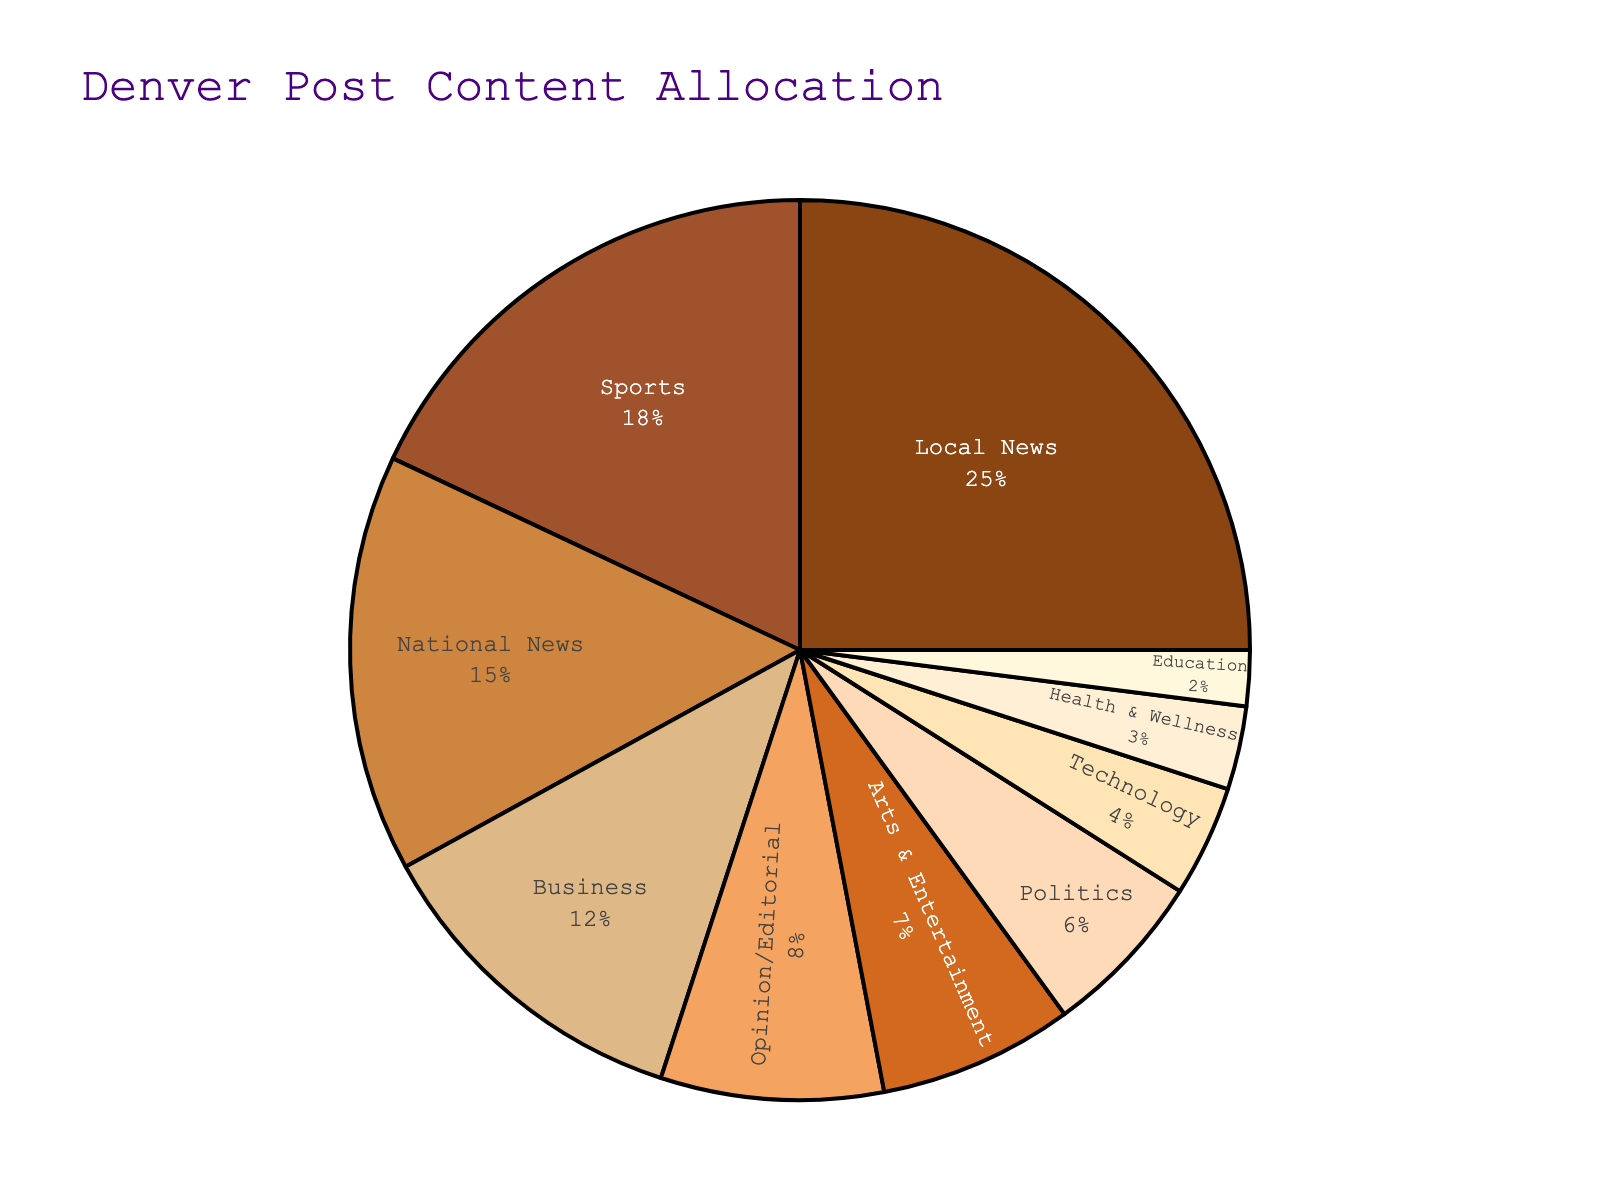What percentage of the Denver Post's content is dedicated to Sports? Locate the 'Sports' section on the pie chart and check the percentage value indicated.
Answer: 18% What sections of content together make up 50% of the Denver Post's content? Sum the largest sections until reaching 50%. The 'Local News' (25%) and 'National News' (15%) alone total 40%. Adding 'Sports' (18%) exceeds 50%. Therefore, the combination 'Local News' (25%), 'National News' (15%), and 'Business' (12%) total 52%.
Answer: Local News, National News, Business Compare the percentage of content dedicated to Politics and Technology. Which one is more? Locate both 'Politics' and 'Technology' sections. 'Politics' is 6% and 'Technology' is 4%. Compare the two values.
Answer: Politics Is 'Arts & Entertainment' a larger section than 'Opinion/Editorial'? Locate both the 'Arts & Entertainment' and 'Opinion/Editorial' sections. Compare their percentages, 7% for 'Arts & Entertainment' and 8% for 'Opinion/Editorial'.
Answer: No What is the combined percentage allocated to Health & Wellness and Education? Sum the percentages for 'Health & Wellness' (3%) and 'Education' (2%). 3% + 2% = 5%.
Answer: 5% Which section has the smallest allocation? Identify the section with the smallest percentage value. 'Education' has the smallest allocation at 2%.
Answer: Education What is the difference in percentage between Business and Politics content? Subtract the percentage of 'Politics' (6%) from 'Business' (12%). 12% - 6% = 6%.
Answer: 6% How many sections have a percentage allocation greater than 10%? Count the sections that have more than 10%. 'Local News' (25%), 'National News' (15%), 'Sports' (18%), and 'Business' (12%). There are 4 sections.
Answer: 4 What percentage of the Denver Post's content is not covered by Local News, National News, or Sports? First, sum the percentages of 'Local News' (25%), 'National News' (15%), and 'Sports' (18%). 25% + 15% + 18% = 58%. Deduct this from 100% to get the percentage not covered by these sections. 100% - 58% = 42%.
Answer: 42% Which color corresponds to the 'Local News' section in the pie chart? Identify the visual attribute (color) that matches the 'Local News' section. This section is usually the first in the pie chart and corresponds to the first color in the sequence used.
Answer: Brown 